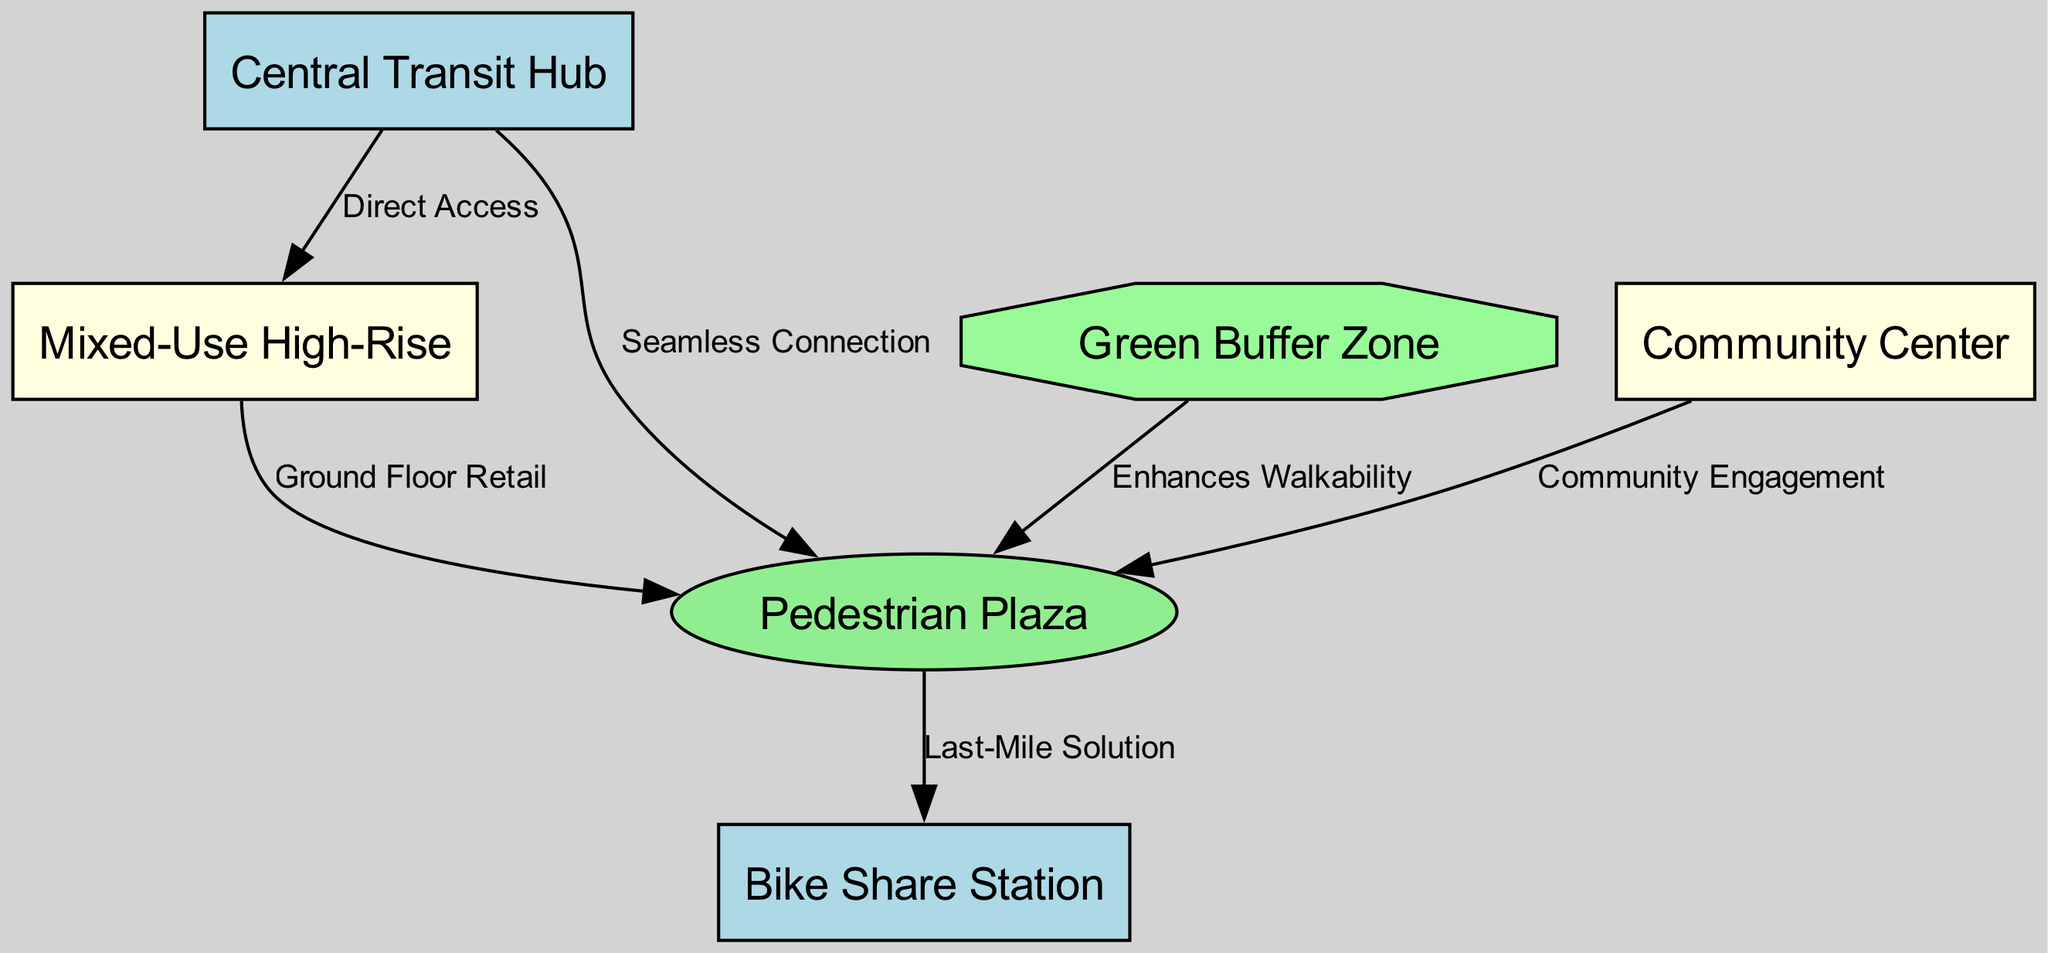What's the total number of nodes in the diagram? The diagram contains a list of nodes, which are items such as the Central Transit Hub, Mixed-Use High-Rise, Pedestrian Plaza, Bike Share Station, Green Buffer Zone, and Community Center. Counting these gives a total of 6 nodes.
Answer: 6 What type of infrastructure is directly connected to the Mixed-Use High-Rise? The diagram shows a direct access edge from the Central Transit Hub to the Mixed-Use High-Rise. This indicates that the Central Transit Hub is the infrastructure directly connected to the Mixed-Use High-Rise.
Answer: Central Transit Hub How many edges connect to the Pedestrian Plaza? Looking at the edges connected to the Pedestrian Plaza, there are four connections: from the Central Transit Hub, Mixed-Use High-Rise, Bike Share Station, and Community Center. Counting these gives a total of 4 edges.
Answer: 4 What type of building is adjacent to the Community Center? The diagram illustrates a connection between the Community Center and the Pedestrian Plaza, implying that the Pedestrian Plaza is adjacent to the Community Center.
Answer: Pedestrian Plaza Which node represents the last-mile solution? The edge labeled "Last-Mile Solution" connects the Pedestrian Plaza to the Bike Share Station, indicating that the Bike Share Station is the node representing the last-mile solution.
Answer: Bike Share Station Explain how the Green Buffer Zone affects user experience in the context of the Pedestrian Plaza. The diagram shows an edge labeled "Enhances Walkability" connecting the Green Buffer Zone to the Pedestrian Plaza. This suggests that the Green Buffer Zone contributes positively to the user experience by promoting walkability in the Pedestrian Plaza, making it a more pleasant space for pedestrians.
Answer: Enhances Walkability Which three elements directly enhance community engagement? The diagram indicates that the Community Center connects to the Pedestrian Plaza and that the Mixed-Use High-Rise has ground floor retail connected to the same plaza. Therefore, the three elements that directly enhance community engagement are the Community Center, Mixed-Use High-Rise, and Pedestrian Plaza.
Answer: Community Center, Mixed-Use High-Rise, Pedestrian Plaza 